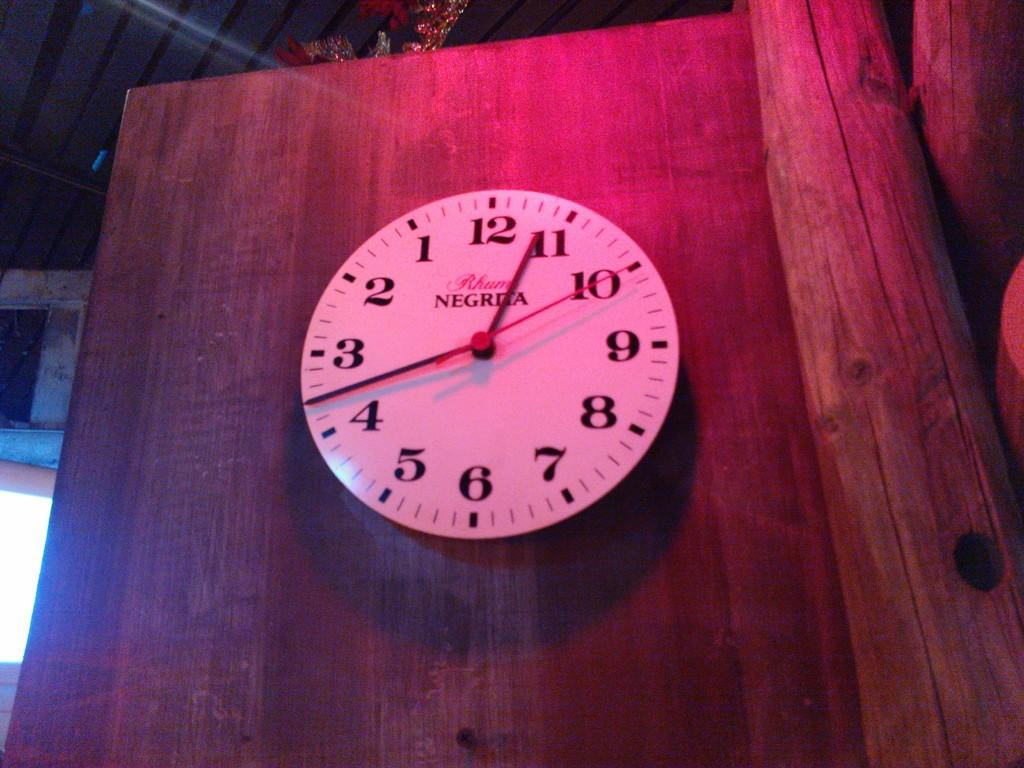<image>
Describe the image concisely. A Negrita clock is hanging on a plain wooden wall. 